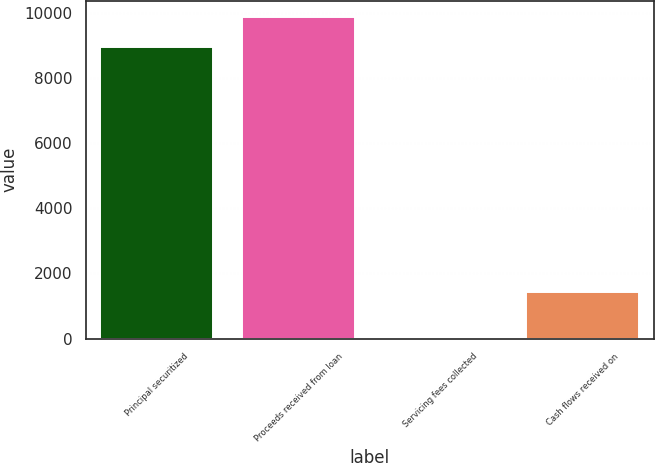Convert chart to OTSL. <chart><loc_0><loc_0><loc_500><loc_500><bar_chart><fcel>Principal securitized<fcel>Proceeds received from loan<fcel>Servicing fees collected<fcel>Cash flows received on<nl><fcel>8964<fcel>9873.1<fcel>3<fcel>1441<nl></chart> 